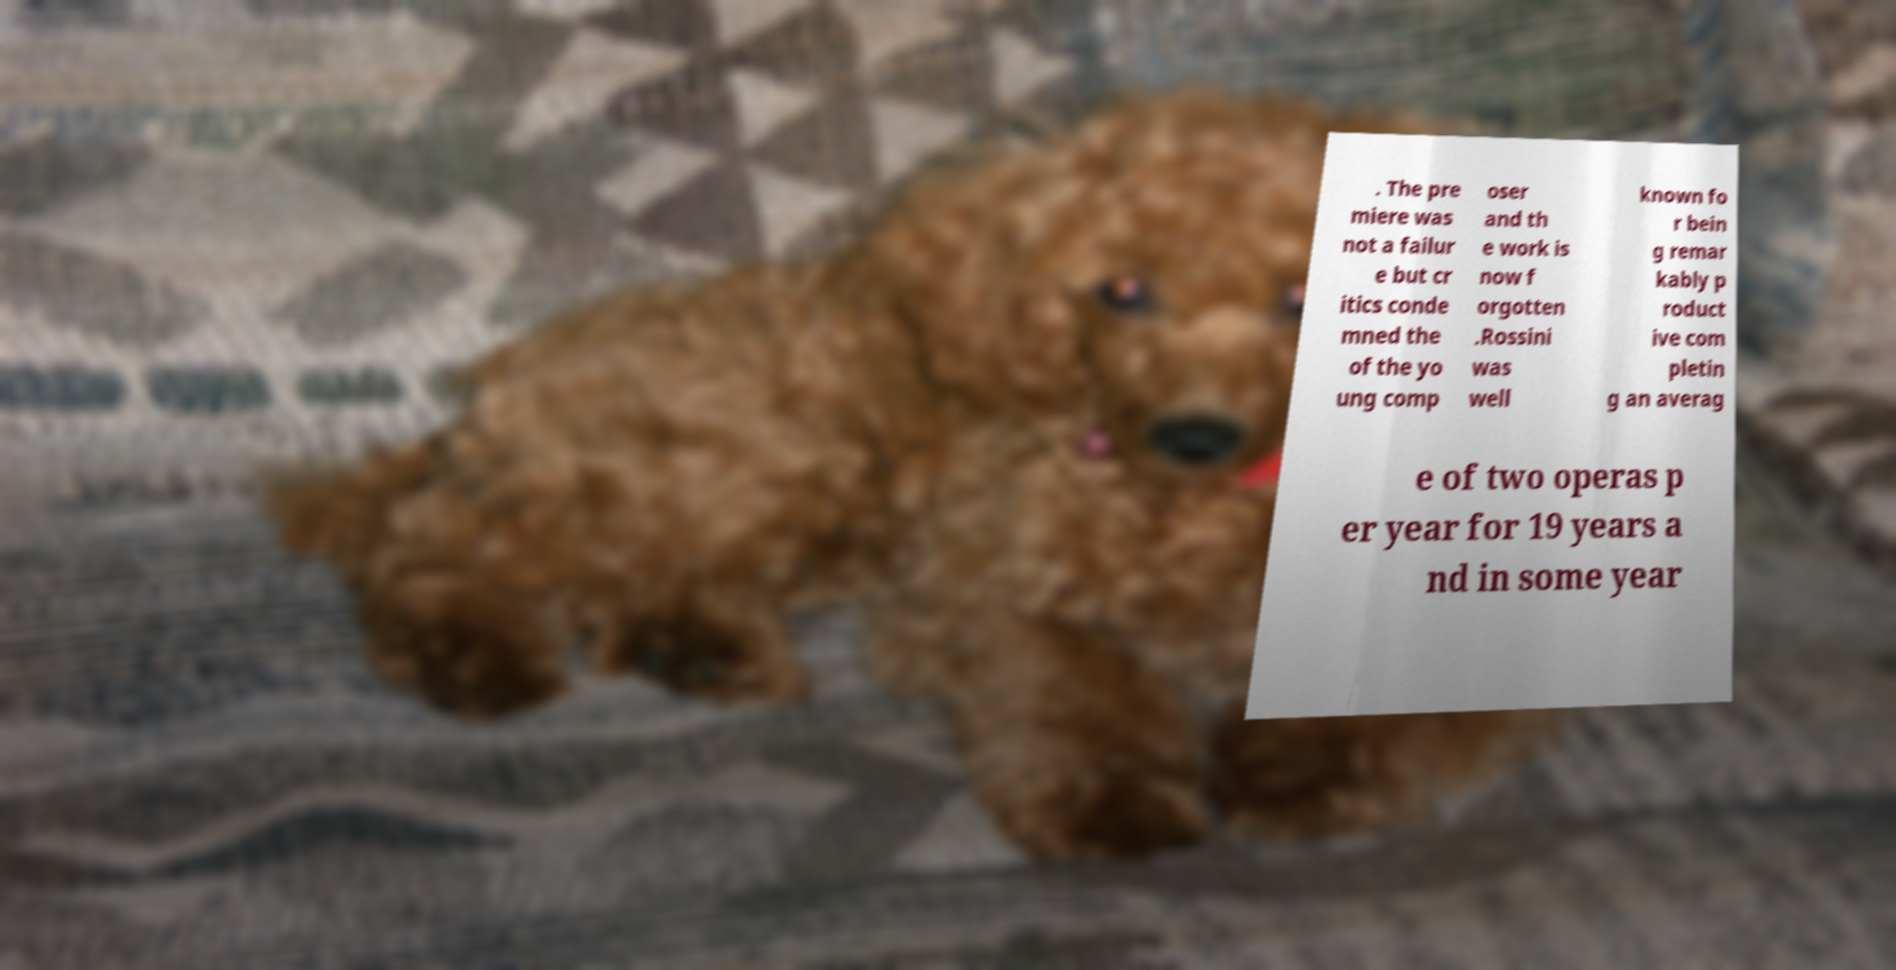I need the written content from this picture converted into text. Can you do that? . The pre miere was not a failur e but cr itics conde mned the of the yo ung comp oser and th e work is now f orgotten .Rossini was well known fo r bein g remar kably p roduct ive com pletin g an averag e of two operas p er year for 19 years a nd in some year 